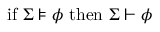<formula> <loc_0><loc_0><loc_500><loc_500>{ i f } \Sigma \models \phi { t h e n } \Sigma \vdash \phi</formula> 